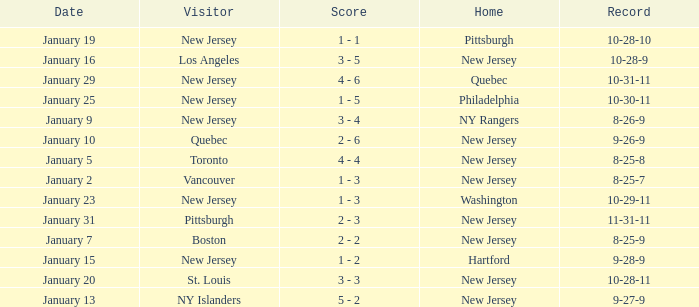What was the home team when the visiting team was Toronto? New Jersey. 